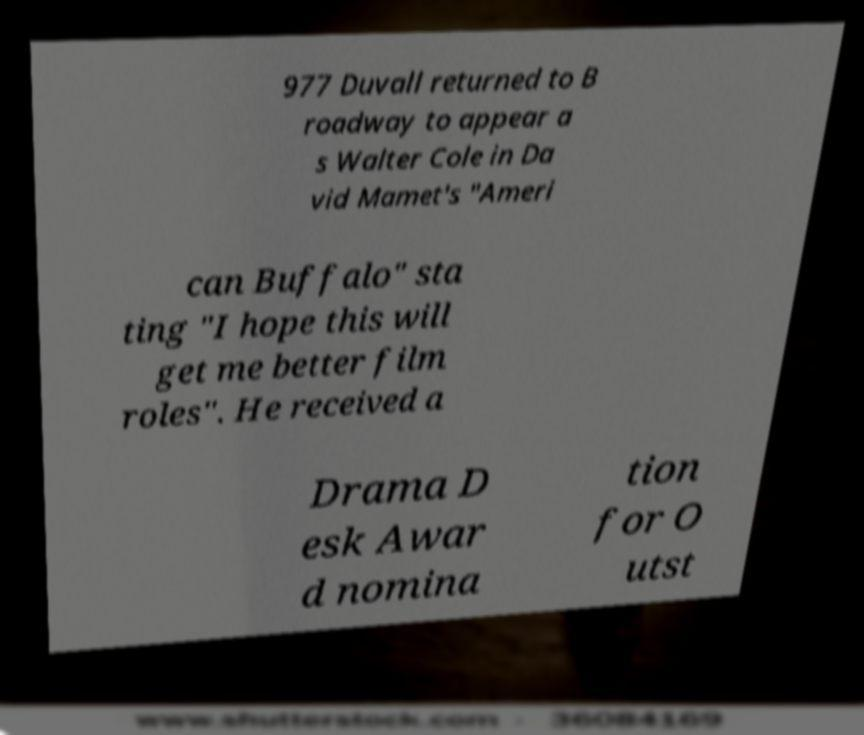Could you assist in decoding the text presented in this image and type it out clearly? 977 Duvall returned to B roadway to appear a s Walter Cole in Da vid Mamet's "Ameri can Buffalo" sta ting "I hope this will get me better film roles". He received a Drama D esk Awar d nomina tion for O utst 